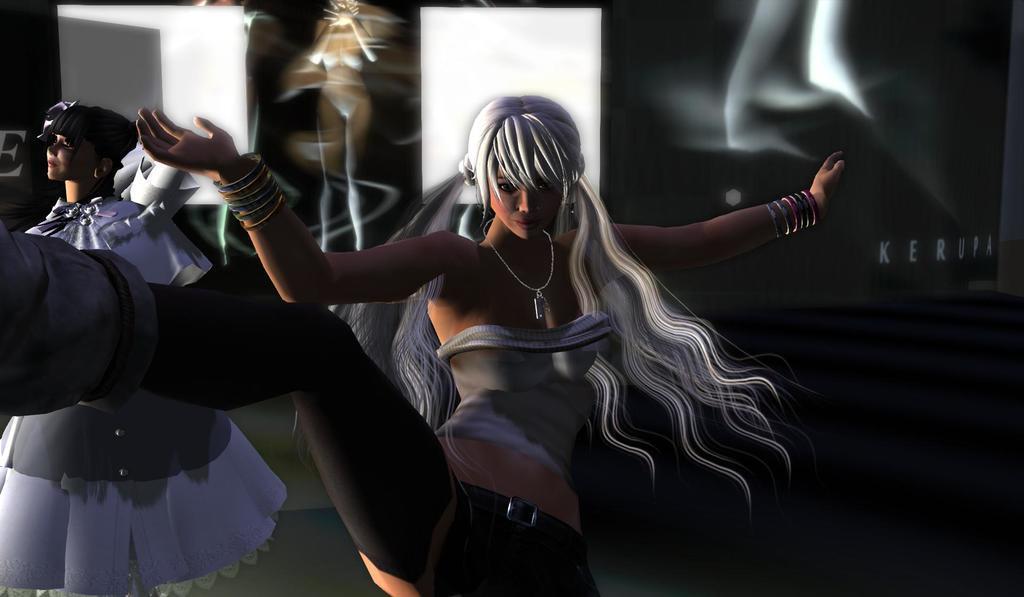Could you give a brief overview of what you see in this image? It is a graphical image. In the center of the image we can see two persons. In the background, we can see some objects. 